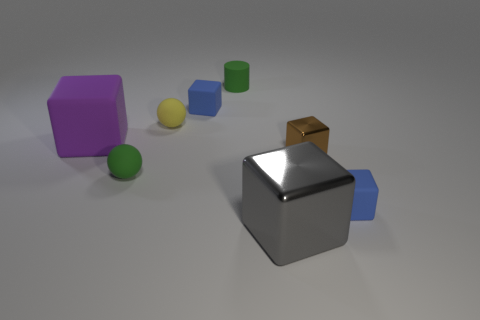There is a small green matte thing in front of the brown shiny thing; what is its shape?
Make the answer very short. Sphere. Is there anything else that has the same shape as the yellow matte thing?
Keep it short and to the point. Yes. Are any blue cylinders visible?
Provide a succinct answer. No. Do the matte cube in front of the brown cube and the brown thing that is right of the gray metallic cube have the same size?
Offer a terse response. Yes. What is the tiny object that is on the left side of the big metallic block and in front of the tiny yellow object made of?
Offer a very short reply. Rubber. There is a brown metal object; how many tiny blocks are in front of it?
Offer a very short reply. 1. Are there any other things that have the same size as the green cylinder?
Give a very brief answer. Yes. The other small sphere that is made of the same material as the green ball is what color?
Give a very brief answer. Yellow. Is the gray thing the same shape as the small metallic object?
Keep it short and to the point. Yes. What number of blue blocks are both behind the brown shiny object and on the right side of the brown object?
Your answer should be very brief. 0. 